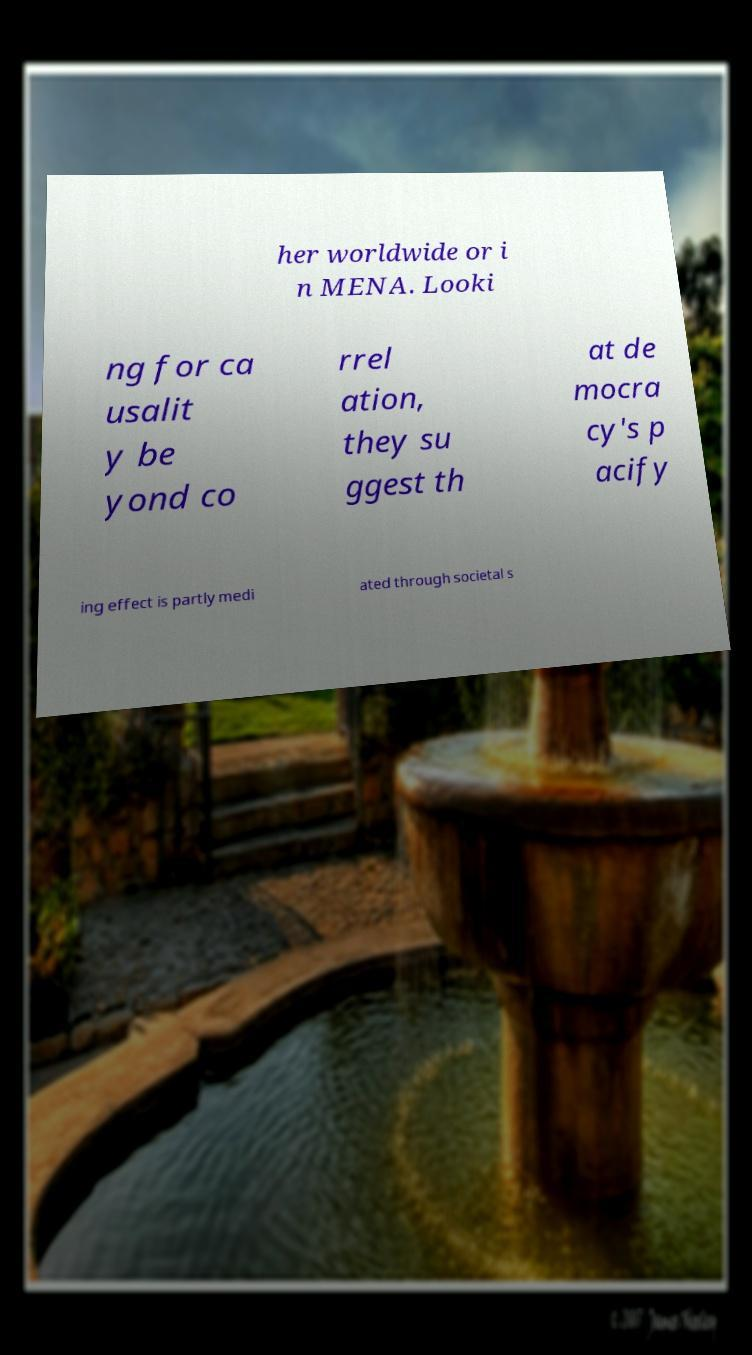There's text embedded in this image that I need extracted. Can you transcribe it verbatim? her worldwide or i n MENA. Looki ng for ca usalit y be yond co rrel ation, they su ggest th at de mocra cy's p acify ing effect is partly medi ated through societal s 